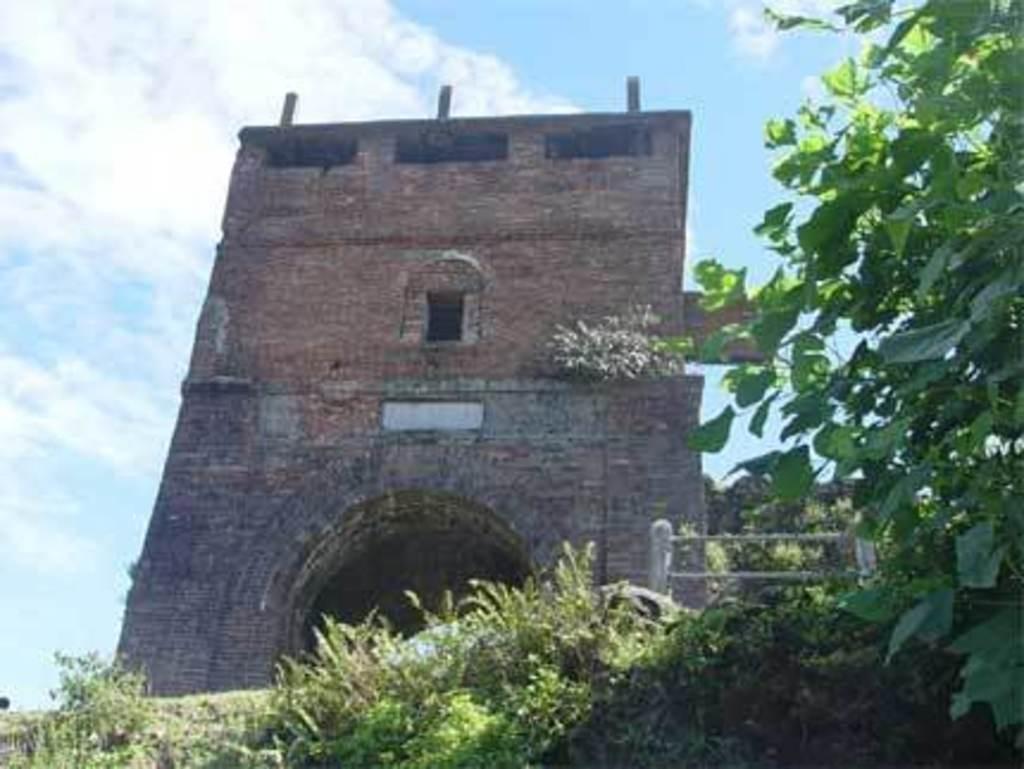Can you describe this image briefly? In this image there is a building, in front of the building there are trees and plants. In the background there is the sky. 